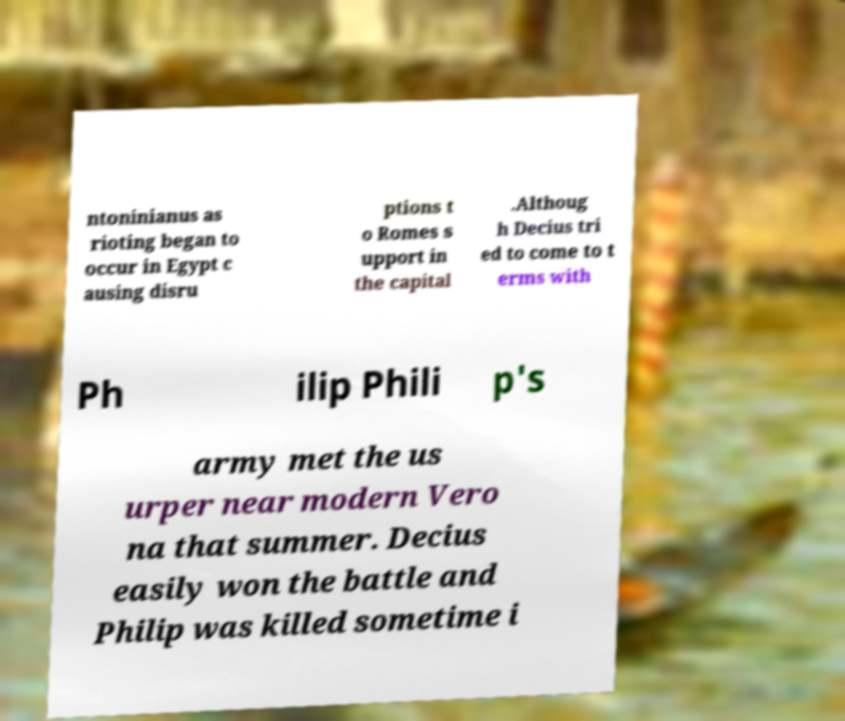Can you accurately transcribe the text from the provided image for me? ntoninianus as rioting began to occur in Egypt c ausing disru ptions t o Romes s upport in the capital .Althoug h Decius tri ed to come to t erms with Ph ilip Phili p's army met the us urper near modern Vero na that summer. Decius easily won the battle and Philip was killed sometime i 